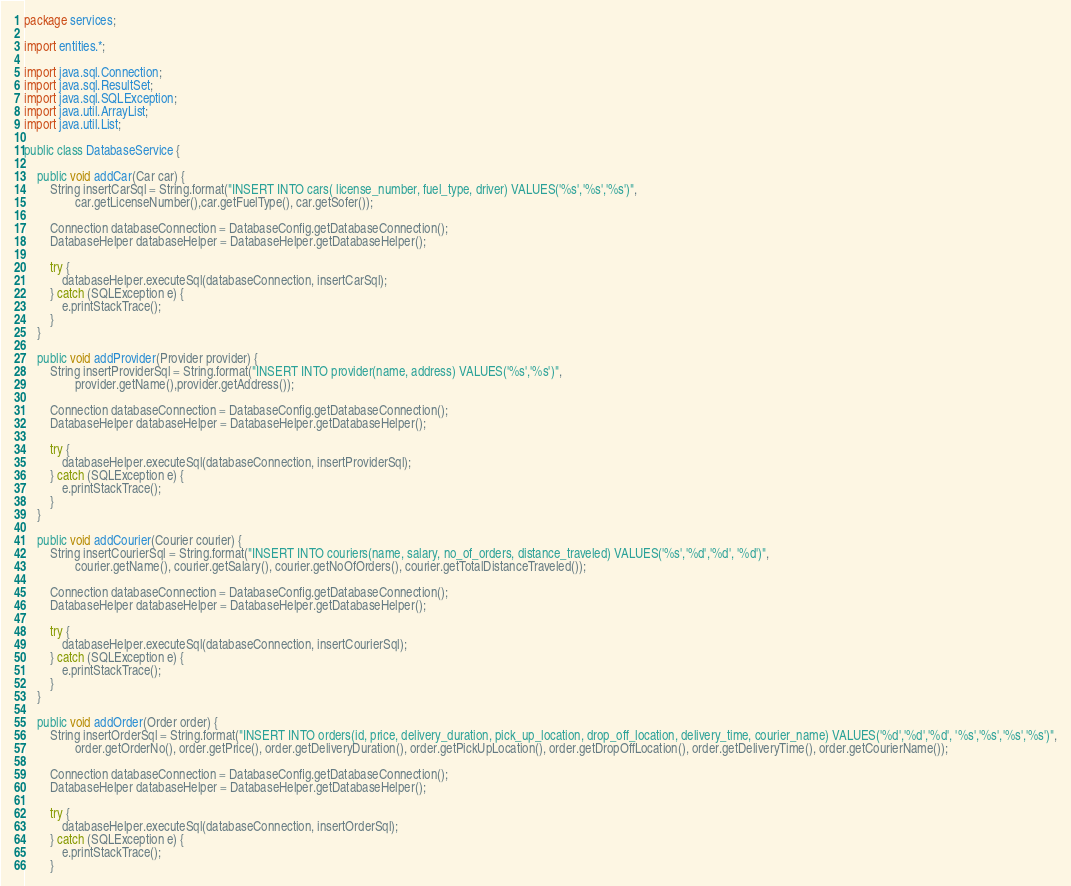<code> <loc_0><loc_0><loc_500><loc_500><_Java_>package services;

import entities.*;

import java.sql.Connection;
import java.sql.ResultSet;
import java.sql.SQLException;
import java.util.ArrayList;
import java.util.List;

public class DatabaseService {

    public void addCar(Car car) {
        String insertCarSql = String.format("INSERT INTO cars( license_number, fuel_type, driver) VALUES('%s','%s','%s')",
                car.getLicenseNumber(),car.getFuelType(), car.getSofer());

        Connection databaseConnection = DatabaseConfig.getDatabaseConnection();
        DatabaseHelper databaseHelper = DatabaseHelper.getDatabaseHelper();

        try {
            databaseHelper.executeSql(databaseConnection, insertCarSql);
        } catch (SQLException e) {
            e.printStackTrace();
        }
    }

    public void addProvider(Provider provider) {
        String insertProviderSql = String.format("INSERT INTO provider(name, address) VALUES('%s','%s')",
                provider.getName(),provider.getAddress());

        Connection databaseConnection = DatabaseConfig.getDatabaseConnection();
        DatabaseHelper databaseHelper = DatabaseHelper.getDatabaseHelper();

        try {
            databaseHelper.executeSql(databaseConnection, insertProviderSql);
        } catch (SQLException e) {
            e.printStackTrace();
        }
    }

    public void addCourier(Courier courier) {
        String insertCourierSql = String.format("INSERT INTO couriers(name, salary, no_of_orders, distance_traveled) VALUES('%s','%d','%d', '%d')",
                courier.getName(), courier.getSalary(), courier.getNoOfOrders(), courier.getTotalDistanceTraveled());

        Connection databaseConnection = DatabaseConfig.getDatabaseConnection();
        DatabaseHelper databaseHelper = DatabaseHelper.getDatabaseHelper();

        try {
            databaseHelper.executeSql(databaseConnection, insertCourierSql);
        } catch (SQLException e) {
            e.printStackTrace();
        }
    }

    public void addOrder(Order order) {
        String insertOrderSql = String.format("INSERT INTO orders(id, price, delivery_duration, pick_up_location, drop_off_location, delivery_time, courier_name) VALUES('%d','%d','%d', '%s','%s','%s','%s')",
                order.getOrderNo(), order.getPrice(), order.getDeliveryDuration(), order.getPickUpLocation(), order.getDropOffLocation(), order.getDeliveryTime(), order.getCourierName());

        Connection databaseConnection = DatabaseConfig.getDatabaseConnection();
        DatabaseHelper databaseHelper = DatabaseHelper.getDatabaseHelper();

        try {
            databaseHelper.executeSql(databaseConnection, insertOrderSql);
        } catch (SQLException e) {
            e.printStackTrace();
        }</code> 